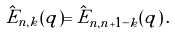<formula> <loc_0><loc_0><loc_500><loc_500>\hat { E } _ { n , k } ( q ) = \hat { E } _ { n , n + 1 - k } ( q ) \, .</formula> 